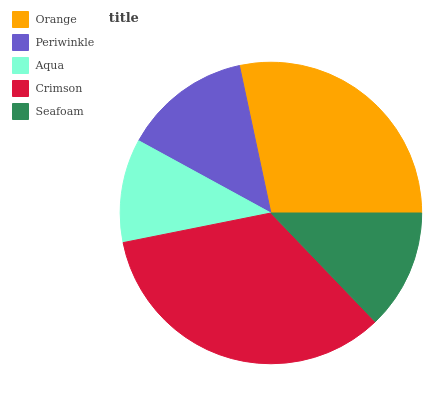Is Aqua the minimum?
Answer yes or no. Yes. Is Crimson the maximum?
Answer yes or no. Yes. Is Periwinkle the minimum?
Answer yes or no. No. Is Periwinkle the maximum?
Answer yes or no. No. Is Orange greater than Periwinkle?
Answer yes or no. Yes. Is Periwinkle less than Orange?
Answer yes or no. Yes. Is Periwinkle greater than Orange?
Answer yes or no. No. Is Orange less than Periwinkle?
Answer yes or no. No. Is Periwinkle the high median?
Answer yes or no. Yes. Is Periwinkle the low median?
Answer yes or no. Yes. Is Seafoam the high median?
Answer yes or no. No. Is Orange the low median?
Answer yes or no. No. 